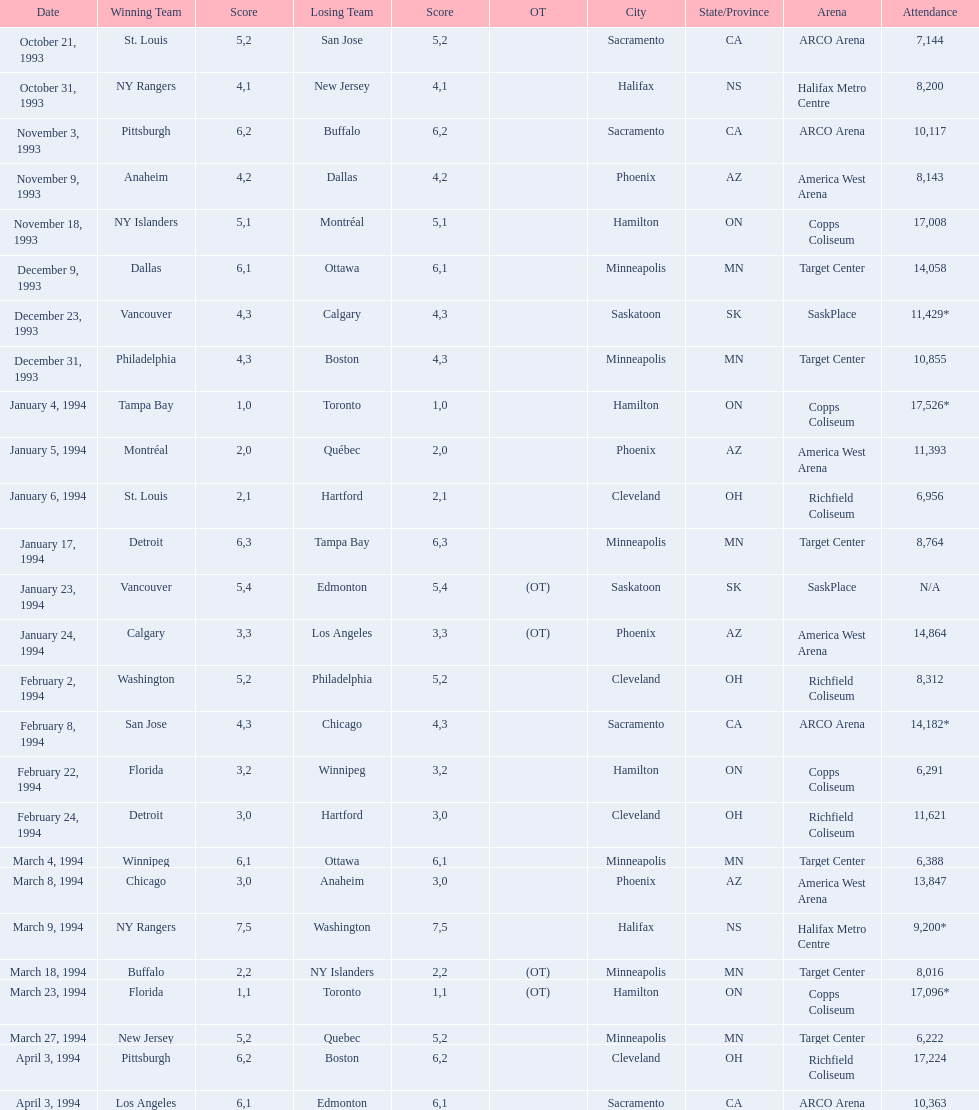Was it dallas or ottawa that won the game on december 9, 1993? Dallas. 